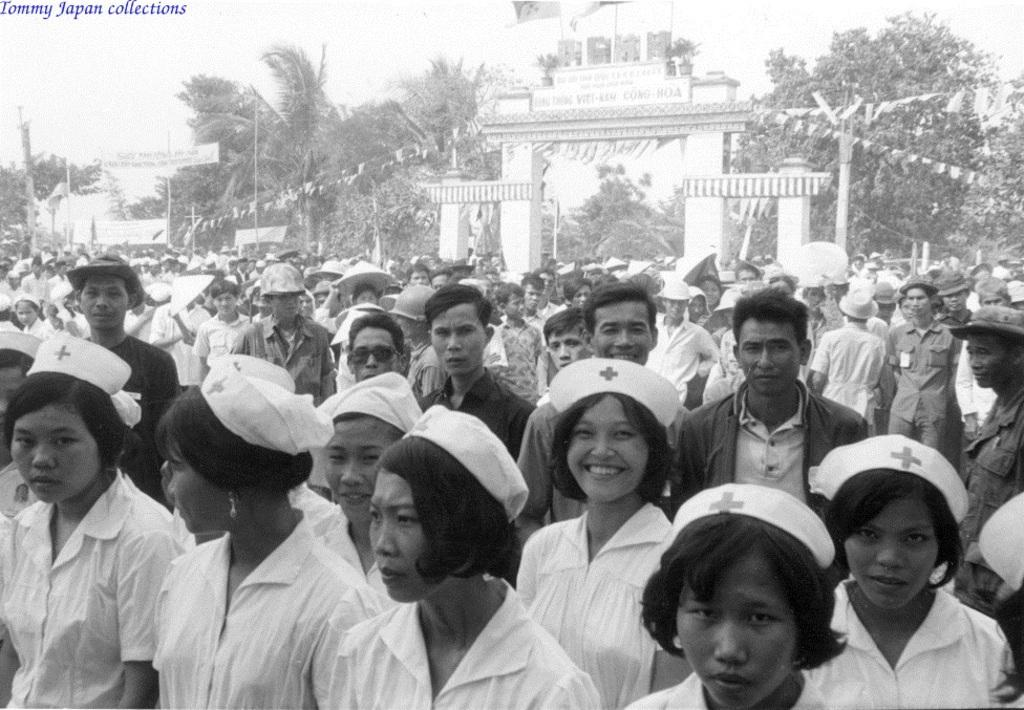Who or what can be seen in the foreground of the image? There are people in the foreground of the image. What can be seen in the background of the image? There are trees, poles, and a poster in the background of the image. What is the purpose of the poles in the background of the image? There is an entrance associated with the poles in the background of the image. What type of reason can be seen in the image? There is no reason present in the image; it features people, trees, poles, and a poster in the background. Are there any bushes visible in the image? There is no mention of bushes in the provided facts, so we cannot definitively say whether they are present or not. 